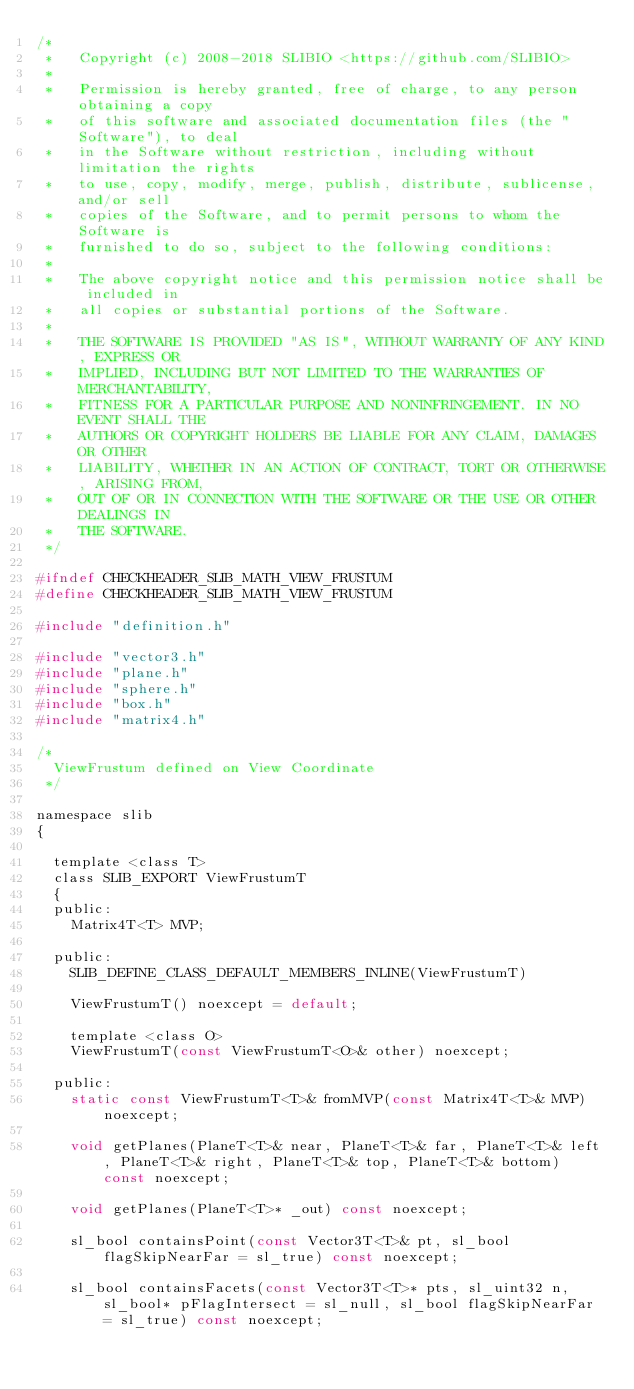<code> <loc_0><loc_0><loc_500><loc_500><_C_>/*
 *   Copyright (c) 2008-2018 SLIBIO <https://github.com/SLIBIO>
 *
 *   Permission is hereby granted, free of charge, to any person obtaining a copy
 *   of this software and associated documentation files (the "Software"), to deal
 *   in the Software without restriction, including without limitation the rights
 *   to use, copy, modify, merge, publish, distribute, sublicense, and/or sell
 *   copies of the Software, and to permit persons to whom the Software is
 *   furnished to do so, subject to the following conditions:
 *
 *   The above copyright notice and this permission notice shall be included in
 *   all copies or substantial portions of the Software.
 *
 *   THE SOFTWARE IS PROVIDED "AS IS", WITHOUT WARRANTY OF ANY KIND, EXPRESS OR
 *   IMPLIED, INCLUDING BUT NOT LIMITED TO THE WARRANTIES OF MERCHANTABILITY,
 *   FITNESS FOR A PARTICULAR PURPOSE AND NONINFRINGEMENT. IN NO EVENT SHALL THE
 *   AUTHORS OR COPYRIGHT HOLDERS BE LIABLE FOR ANY CLAIM, DAMAGES OR OTHER
 *   LIABILITY, WHETHER IN AN ACTION OF CONTRACT, TORT OR OTHERWISE, ARISING FROM,
 *   OUT OF OR IN CONNECTION WITH THE SOFTWARE OR THE USE OR OTHER DEALINGS IN
 *   THE SOFTWARE.
 */

#ifndef CHECKHEADER_SLIB_MATH_VIEW_FRUSTUM
#define CHECKHEADER_SLIB_MATH_VIEW_FRUSTUM

#include "definition.h"

#include "vector3.h"
#include "plane.h"
#include "sphere.h"
#include "box.h"
#include "matrix4.h"

/*
	ViewFrustum defined on View Coordinate
 */

namespace slib
{

	template <class T>
	class SLIB_EXPORT ViewFrustumT
	{
	public:
		Matrix4T<T> MVP;

	public:
		SLIB_DEFINE_CLASS_DEFAULT_MEMBERS_INLINE(ViewFrustumT)
		
		ViewFrustumT() noexcept = default;

		template <class O>
		ViewFrustumT(const ViewFrustumT<O>& other) noexcept;

	public:
		static const ViewFrustumT<T>& fromMVP(const Matrix4T<T>& MVP) noexcept;

		void getPlanes(PlaneT<T>& near, PlaneT<T>& far, PlaneT<T>& left, PlaneT<T>& right, PlaneT<T>& top, PlaneT<T>& bottom) const noexcept;

		void getPlanes(PlaneT<T>* _out) const noexcept;

		sl_bool containsPoint(const Vector3T<T>& pt, sl_bool flagSkipNearFar = sl_true) const noexcept;

		sl_bool containsFacets(const Vector3T<T>* pts, sl_uint32 n, sl_bool* pFlagIntersect = sl_null, sl_bool flagSkipNearFar = sl_true) const noexcept;
</code> 